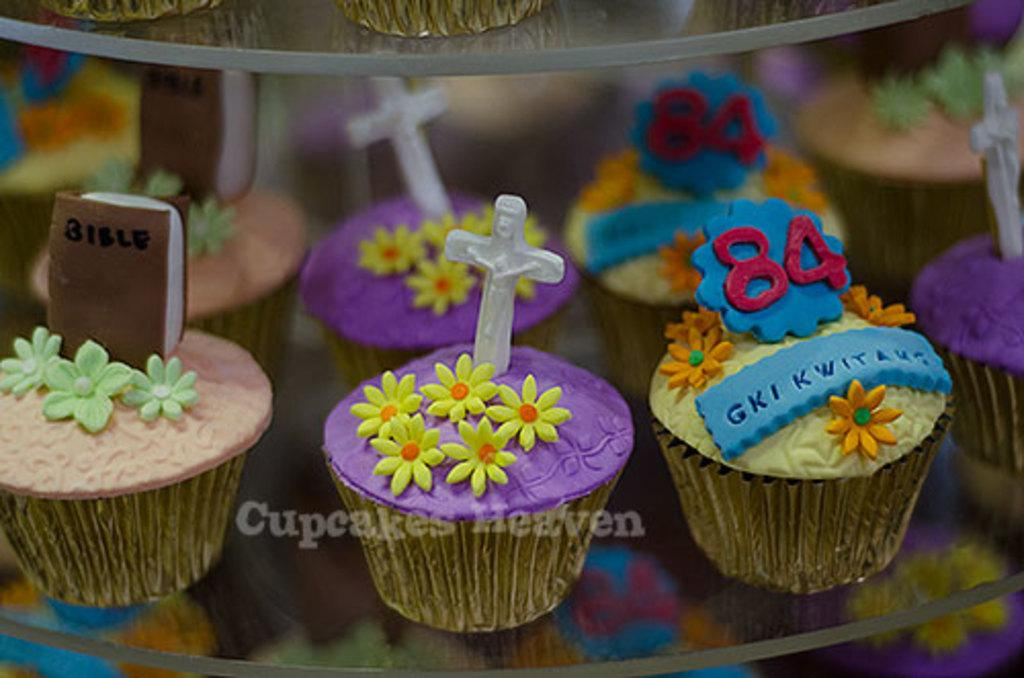What type of food is shown in the image? There are cupcakes in the image. Are there any additional items placed on the cupcakes? Yes, there is a book on one of the cupcakes and a holy cross symbol on another cupcake. What type of farm animals can be seen grazing in the image? There are no farm animals present in the image; it features cupcakes with a book and a holy cross symbol. 